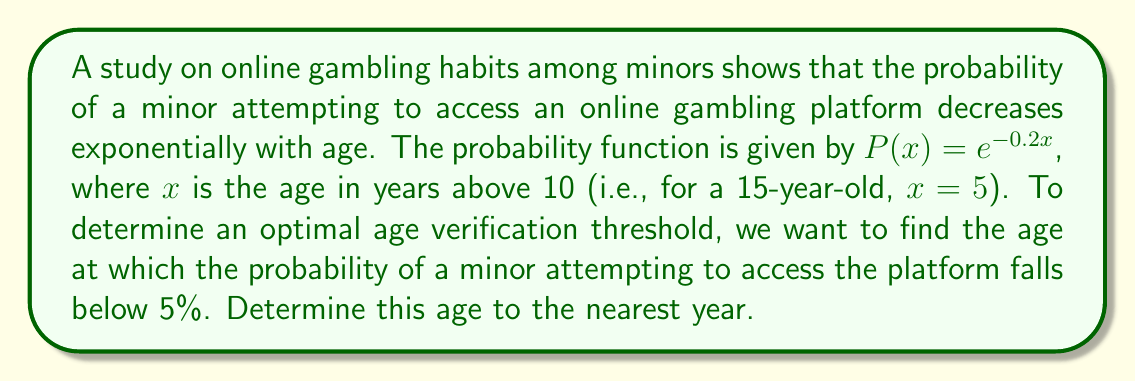Could you help me with this problem? To solve this problem, we need to follow these steps:

1) We are looking for the value of $x$ where $P(x) < 0.05$

2) Set up the equation:
   $$e^{-0.2x} = 0.05$$

3) Take the natural logarithm of both sides:
   $$\ln(e^{-0.2x}) = \ln(0.05)$$
   $$-0.2x = \ln(0.05)$$

4) Solve for $x$:
   $$x = -\frac{\ln(0.05)}{0.2}$$

5) Calculate the value:
   $$x \approx 14.979$$

6) Remember that $x$ represents years above 10, so add 10:
   $$14.979 + 10 \approx 24.979$$

7) Round to the nearest year:
   $$25 \text{ years old}$$

Therefore, the optimal age verification threshold is 25 years old.
Answer: 25 years old 